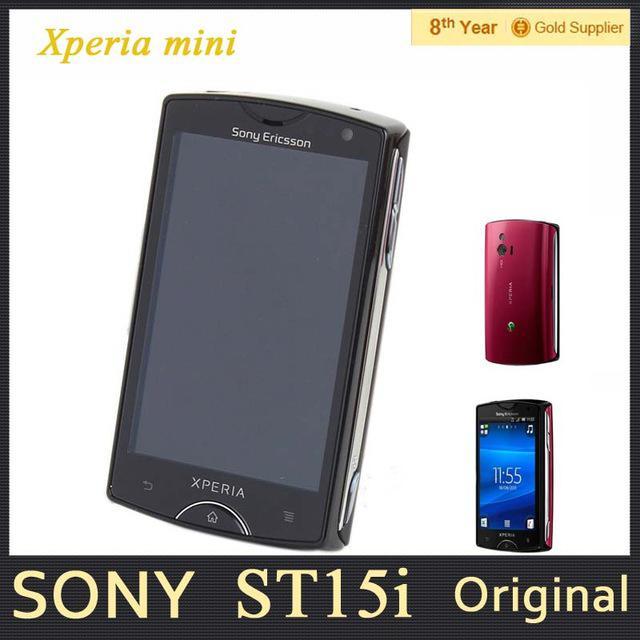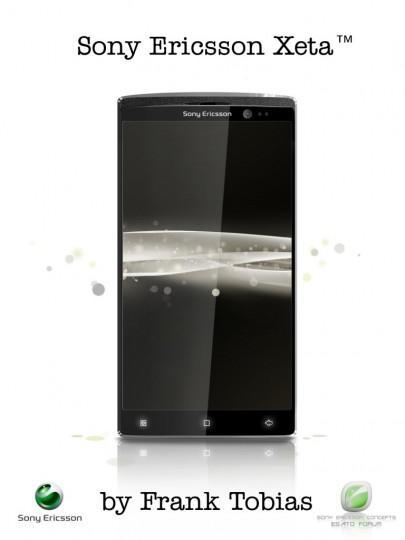The first image is the image on the left, the second image is the image on the right. Given the left and right images, does the statement "Each image in the pair shows multiple views of a mobile device." hold true? Answer yes or no. No. The first image is the image on the left, the second image is the image on the right. Examine the images to the left and right. Is the description "The combined images include at least one side view of a device, at least two front views of a device with an image on the screen, and at least one head-on view of the back of a device." accurate? Answer yes or no. No. 